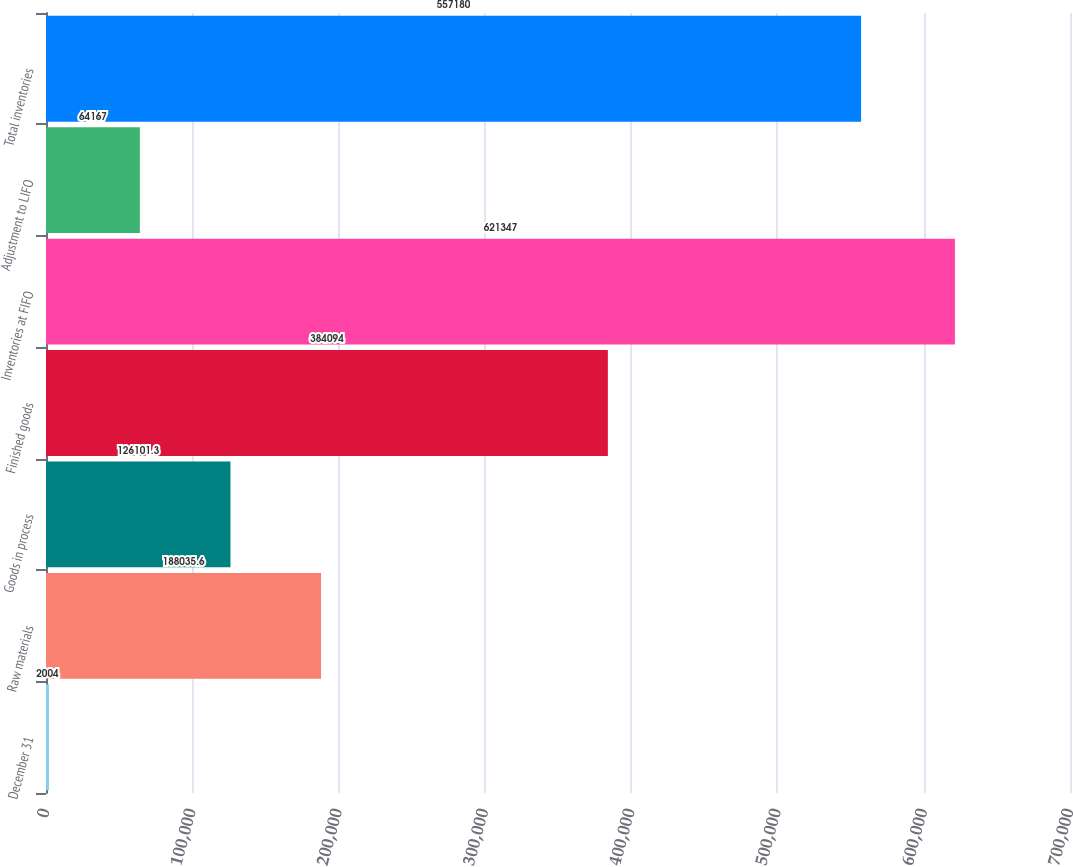Convert chart. <chart><loc_0><loc_0><loc_500><loc_500><bar_chart><fcel>December 31<fcel>Raw materials<fcel>Goods in process<fcel>Finished goods<fcel>Inventories at FIFO<fcel>Adjustment to LIFO<fcel>Total inventories<nl><fcel>2004<fcel>188036<fcel>126101<fcel>384094<fcel>621347<fcel>64167<fcel>557180<nl></chart> 